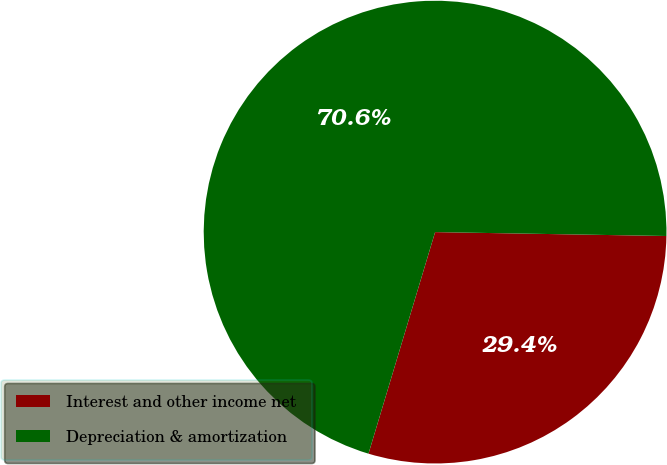Convert chart. <chart><loc_0><loc_0><loc_500><loc_500><pie_chart><fcel>Interest and other income net<fcel>Depreciation & amortization<nl><fcel>29.38%<fcel>70.62%<nl></chart> 